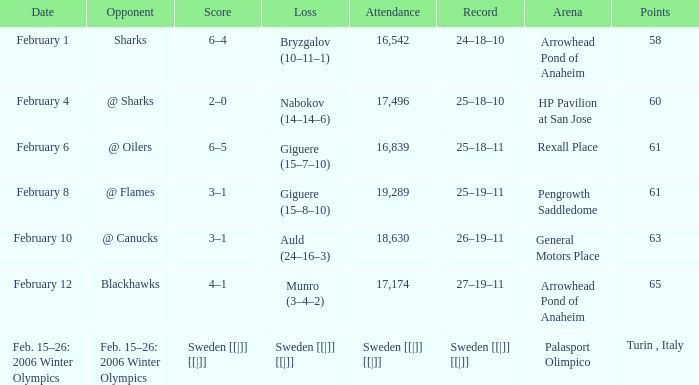What is the record at Palasport Olimpico? Sweden [[|]] [[|]]. 